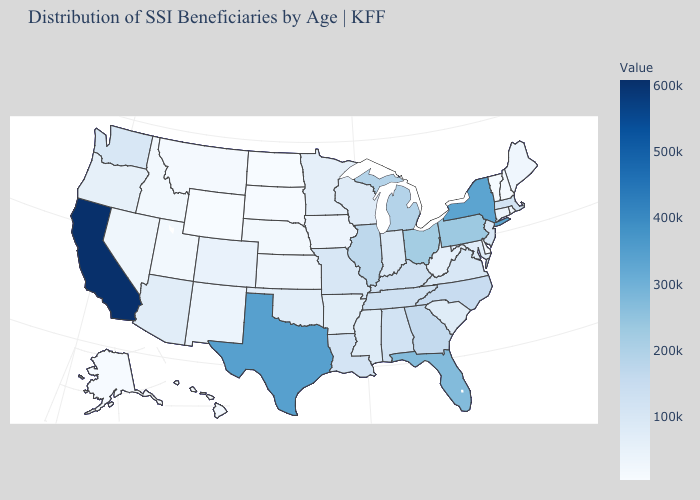Is the legend a continuous bar?
Keep it brief. Yes. Which states hav the highest value in the MidWest?
Answer briefly. Ohio. Which states have the highest value in the USA?
Be succinct. California. Among the states that border Wisconsin , which have the highest value?
Quick response, please. Michigan. Does Utah have the lowest value in the West?
Answer briefly. No. Does Montana have a lower value than Tennessee?
Give a very brief answer. Yes. Among the states that border South Dakota , does Minnesota have the lowest value?
Be succinct. No. 